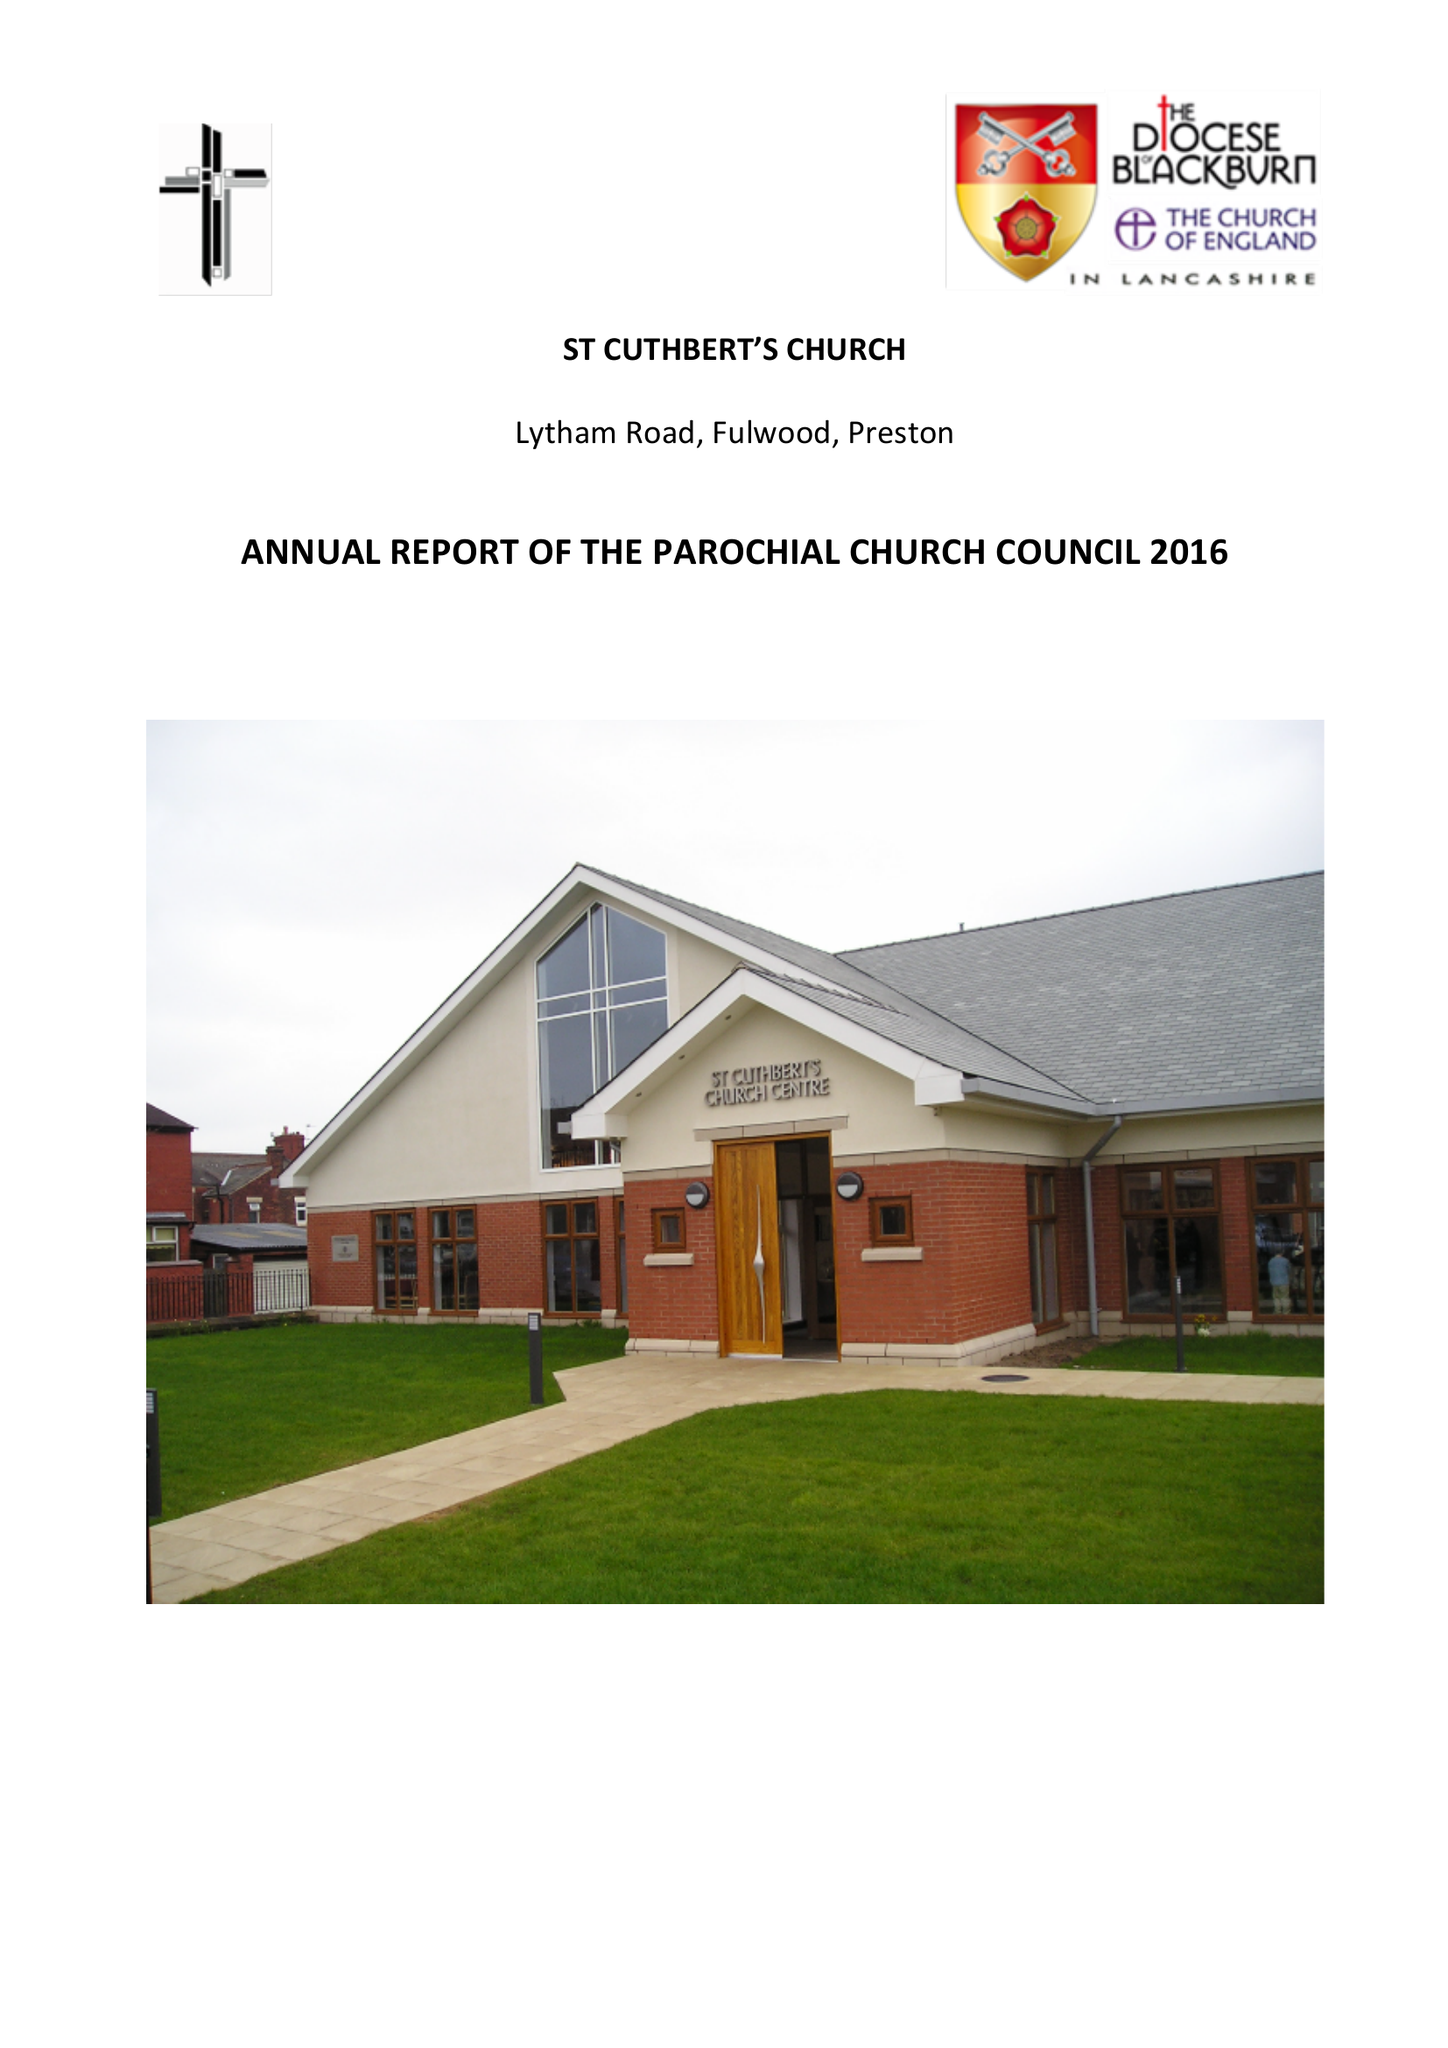What is the value for the charity_number?
Answer the question using a single word or phrase. 1127997 